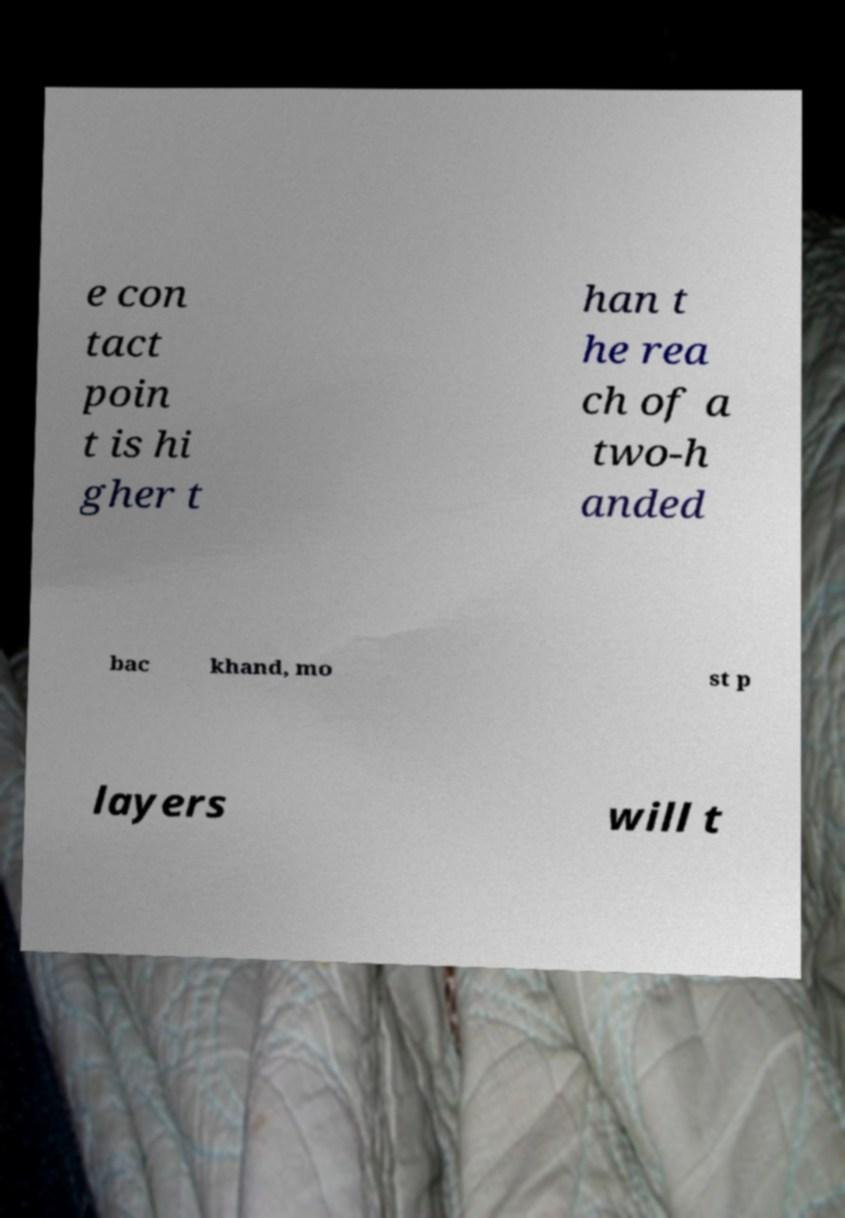What messages or text are displayed in this image? I need them in a readable, typed format. e con tact poin t is hi gher t han t he rea ch of a two-h anded bac khand, mo st p layers will t 